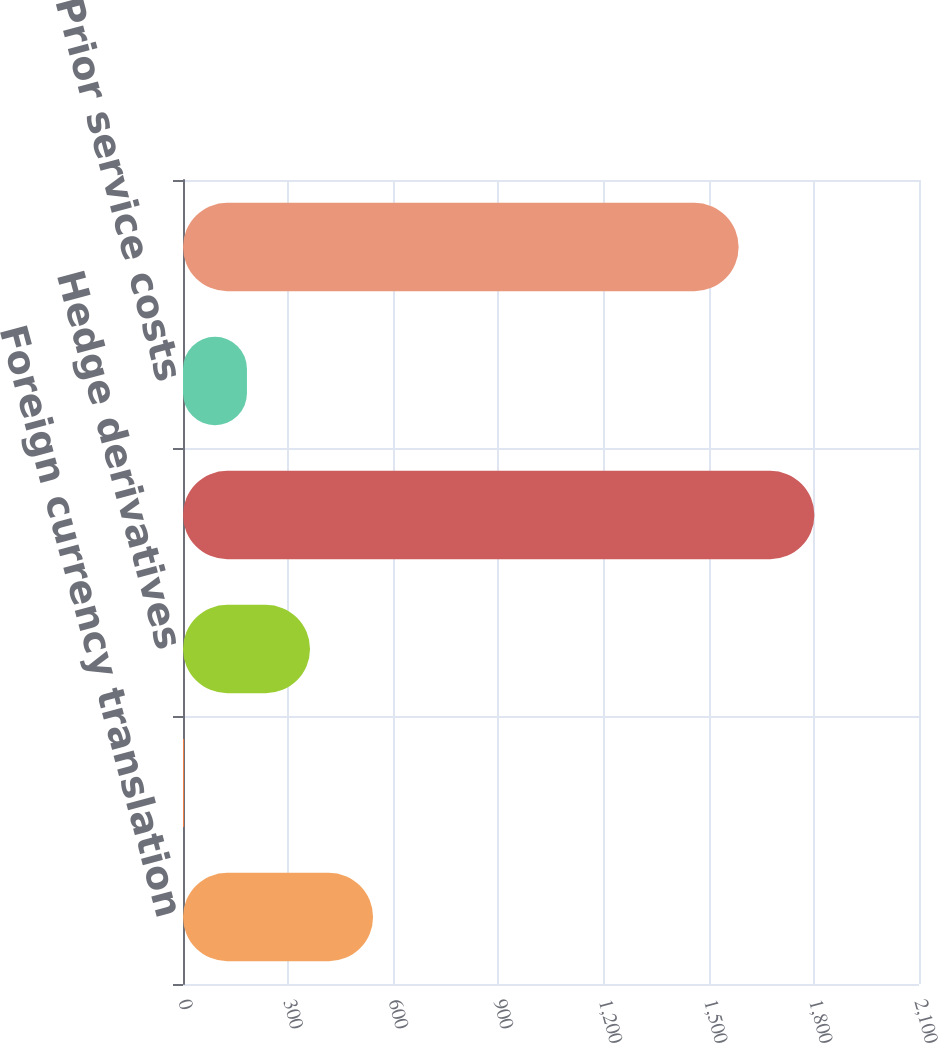Convert chart to OTSL. <chart><loc_0><loc_0><loc_500><loc_500><bar_chart><fcel>Foreign currency translation<fcel>Securities<fcel>Hedge derivatives<fcel>Net actuarial loss<fcel>Prior service costs<fcel>Accumulated other<nl><fcel>542.27<fcel>2.6<fcel>362.38<fcel>1801.5<fcel>182.49<fcel>1585.3<nl></chart> 